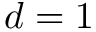Convert formula to latex. <formula><loc_0><loc_0><loc_500><loc_500>d = 1</formula> 